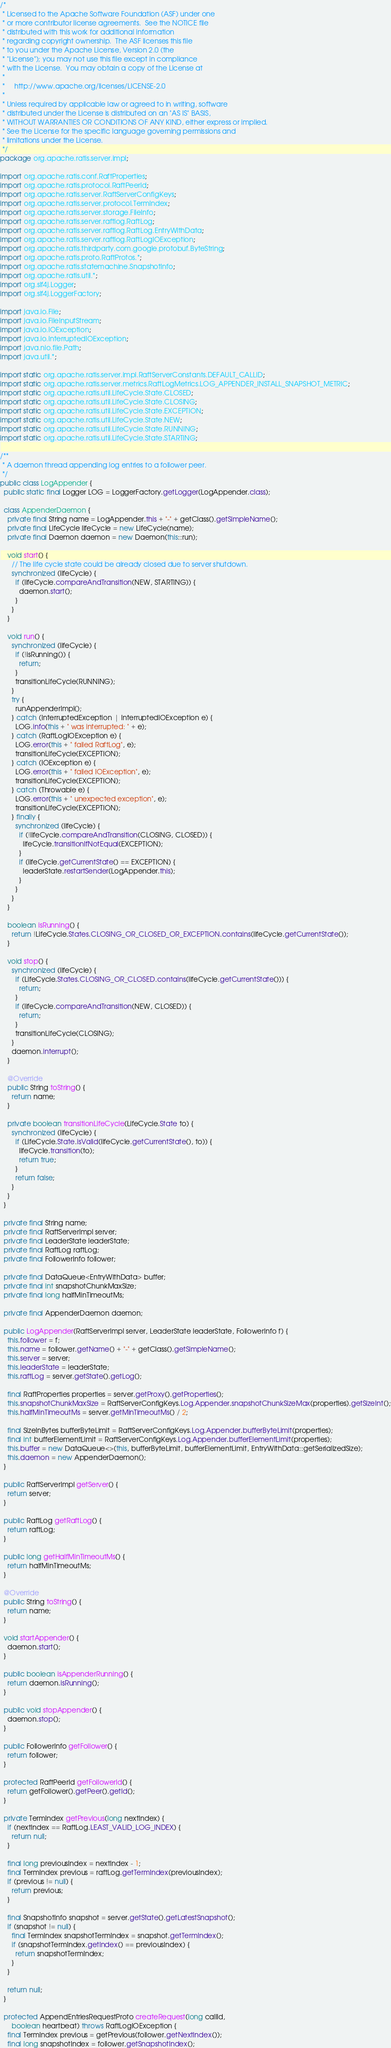<code> <loc_0><loc_0><loc_500><loc_500><_Java_>/*
 * Licensed to the Apache Software Foundation (ASF) under one
 * or more contributor license agreements.  See the NOTICE file
 * distributed with this work for additional information
 * regarding copyright ownership.  The ASF licenses this file
 * to you under the Apache License, Version 2.0 (the
 * "License"); you may not use this file except in compliance
 * with the License.  You may obtain a copy of the License at
 *
 *     http://www.apache.org/licenses/LICENSE-2.0
 *
 * Unless required by applicable law or agreed to in writing, software
 * distributed under the License is distributed on an "AS IS" BASIS,
 * WITHOUT WARRANTIES OR CONDITIONS OF ANY KIND, either express or implied.
 * See the License for the specific language governing permissions and
 * limitations under the License.
 */
package org.apache.ratis.server.impl;

import org.apache.ratis.conf.RaftProperties;
import org.apache.ratis.protocol.RaftPeerId;
import org.apache.ratis.server.RaftServerConfigKeys;
import org.apache.ratis.server.protocol.TermIndex;
import org.apache.ratis.server.storage.FileInfo;
import org.apache.ratis.server.raftlog.RaftLog;
import org.apache.ratis.server.raftlog.RaftLog.EntryWithData;
import org.apache.ratis.server.raftlog.RaftLogIOException;
import org.apache.ratis.thirdparty.com.google.protobuf.ByteString;
import org.apache.ratis.proto.RaftProtos.*;
import org.apache.ratis.statemachine.SnapshotInfo;
import org.apache.ratis.util.*;
import org.slf4j.Logger;
import org.slf4j.LoggerFactory;

import java.io.File;
import java.io.FileInputStream;
import java.io.IOException;
import java.io.InterruptedIOException;
import java.nio.file.Path;
import java.util.*;

import static org.apache.ratis.server.impl.RaftServerConstants.DEFAULT_CALLID;
import static org.apache.ratis.server.metrics.RaftLogMetrics.LOG_APPENDER_INSTALL_SNAPSHOT_METRIC;
import static org.apache.ratis.util.LifeCycle.State.CLOSED;
import static org.apache.ratis.util.LifeCycle.State.CLOSING;
import static org.apache.ratis.util.LifeCycle.State.EXCEPTION;
import static org.apache.ratis.util.LifeCycle.State.NEW;
import static org.apache.ratis.util.LifeCycle.State.RUNNING;
import static org.apache.ratis.util.LifeCycle.State.STARTING;

/**
 * A daemon thread appending log entries to a follower peer.
 */
public class LogAppender {
  public static final Logger LOG = LoggerFactory.getLogger(LogAppender.class);

  class AppenderDaemon {
    private final String name = LogAppender.this + "-" + getClass().getSimpleName();
    private final LifeCycle lifeCycle = new LifeCycle(name);
    private final Daemon daemon = new Daemon(this::run);

    void start() {
      // The life cycle state could be already closed due to server shutdown.
      synchronized (lifeCycle) {
        if (lifeCycle.compareAndTransition(NEW, STARTING)) {
          daemon.start();
        }
      }
    }

    void run() {
      synchronized (lifeCycle) {
        if (!isRunning()) {
          return;
        }
        transitionLifeCycle(RUNNING);
      }
      try {
        runAppenderImpl();
      } catch (InterruptedException | InterruptedIOException e) {
        LOG.info(this + " was interrupted: " + e);
      } catch (RaftLogIOException e) {
        LOG.error(this + " failed RaftLog", e);
        transitionLifeCycle(EXCEPTION);
      } catch (IOException e) {
        LOG.error(this + " failed IOException", e);
        transitionLifeCycle(EXCEPTION);
      } catch (Throwable e) {
        LOG.error(this + " unexpected exception", e);
        transitionLifeCycle(EXCEPTION);
      } finally {
        synchronized (lifeCycle) {
          if (!lifeCycle.compareAndTransition(CLOSING, CLOSED)) {
            lifeCycle.transitionIfNotEqual(EXCEPTION);
          }
          if (lifeCycle.getCurrentState() == EXCEPTION) {
            leaderState.restartSender(LogAppender.this);
          }
        }
      }
    }

    boolean isRunning() {
      return !LifeCycle.States.CLOSING_OR_CLOSED_OR_EXCEPTION.contains(lifeCycle.getCurrentState());
    }

    void stop() {
      synchronized (lifeCycle) {
        if (LifeCycle.States.CLOSING_OR_CLOSED.contains(lifeCycle.getCurrentState())) {
          return;
        }
        if (lifeCycle.compareAndTransition(NEW, CLOSED)) {
          return;
        }
        transitionLifeCycle(CLOSING);
      }
      daemon.interrupt();
    }

    @Override
    public String toString() {
      return name;
    }

    private boolean transitionLifeCycle(LifeCycle.State to) {
      synchronized (lifeCycle) {
        if (LifeCycle.State.isValid(lifeCycle.getCurrentState(), to)) {
          lifeCycle.transition(to);
          return true;
        }
        return false;
      }
    }
  }

  private final String name;
  private final RaftServerImpl server;
  private final LeaderState leaderState;
  private final RaftLog raftLog;
  private final FollowerInfo follower;

  private final DataQueue<EntryWithData> buffer;
  private final int snapshotChunkMaxSize;
  private final long halfMinTimeoutMs;

  private final AppenderDaemon daemon;

  public LogAppender(RaftServerImpl server, LeaderState leaderState, FollowerInfo f) {
    this.follower = f;
    this.name = follower.getName() + "-" + getClass().getSimpleName();
    this.server = server;
    this.leaderState = leaderState;
    this.raftLog = server.getState().getLog();

    final RaftProperties properties = server.getProxy().getProperties();
    this.snapshotChunkMaxSize = RaftServerConfigKeys.Log.Appender.snapshotChunkSizeMax(properties).getSizeInt();
    this.halfMinTimeoutMs = server.getMinTimeoutMs() / 2;

    final SizeInBytes bufferByteLimit = RaftServerConfigKeys.Log.Appender.bufferByteLimit(properties);
    final int bufferElementLimit = RaftServerConfigKeys.Log.Appender.bufferElementLimit(properties);
    this.buffer = new DataQueue<>(this, bufferByteLimit, bufferElementLimit, EntryWithData::getSerializedSize);
    this.daemon = new AppenderDaemon();
  }

  public RaftServerImpl getServer() {
    return server;
  }

  public RaftLog getRaftLog() {
    return raftLog;
  }

  public long getHalfMinTimeoutMs() {
    return halfMinTimeoutMs;
  }

  @Override
  public String toString() {
    return name;
  }

  void startAppender() {
    daemon.start();
  }

  public boolean isAppenderRunning() {
    return daemon.isRunning();
  }

  public void stopAppender() {
    daemon.stop();
  }

  public FollowerInfo getFollower() {
    return follower;
  }

  protected RaftPeerId getFollowerId() {
    return getFollower().getPeer().getId();
  }

  private TermIndex getPrevious(long nextIndex) {
    if (nextIndex == RaftLog.LEAST_VALID_LOG_INDEX) {
      return null;
    }

    final long previousIndex = nextIndex - 1;
    final TermIndex previous = raftLog.getTermIndex(previousIndex);
    if (previous != null) {
      return previous;
    }

    final SnapshotInfo snapshot = server.getState().getLatestSnapshot();
    if (snapshot != null) {
      final TermIndex snapshotTermIndex = snapshot.getTermIndex();
      if (snapshotTermIndex.getIndex() == previousIndex) {
        return snapshotTermIndex;
      }
    }

    return null;
  }

  protected AppendEntriesRequestProto createRequest(long callId,
      boolean heartbeat) throws RaftLogIOException {
    final TermIndex previous = getPrevious(follower.getNextIndex());
    final long snapshotIndex = follower.getSnapshotIndex();</code> 